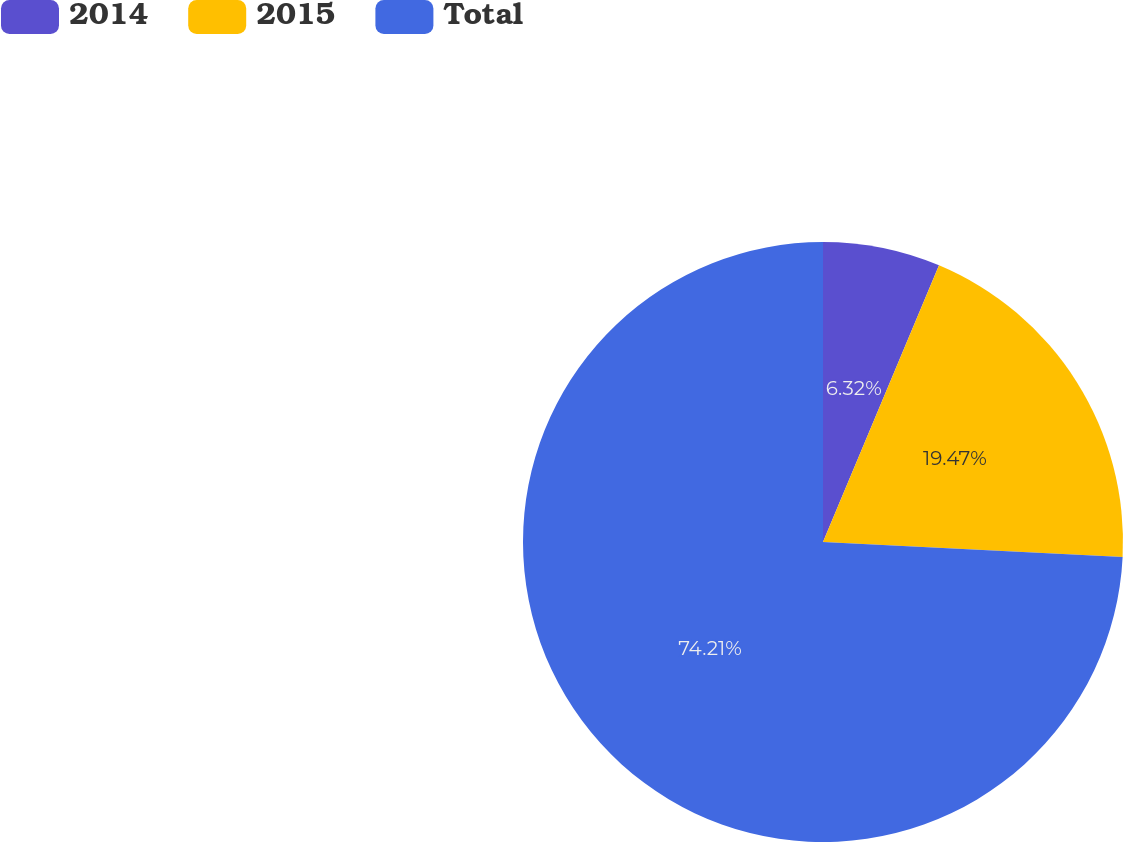<chart> <loc_0><loc_0><loc_500><loc_500><pie_chart><fcel>2014<fcel>2015<fcel>Total<nl><fcel>6.32%<fcel>19.47%<fcel>74.21%<nl></chart> 